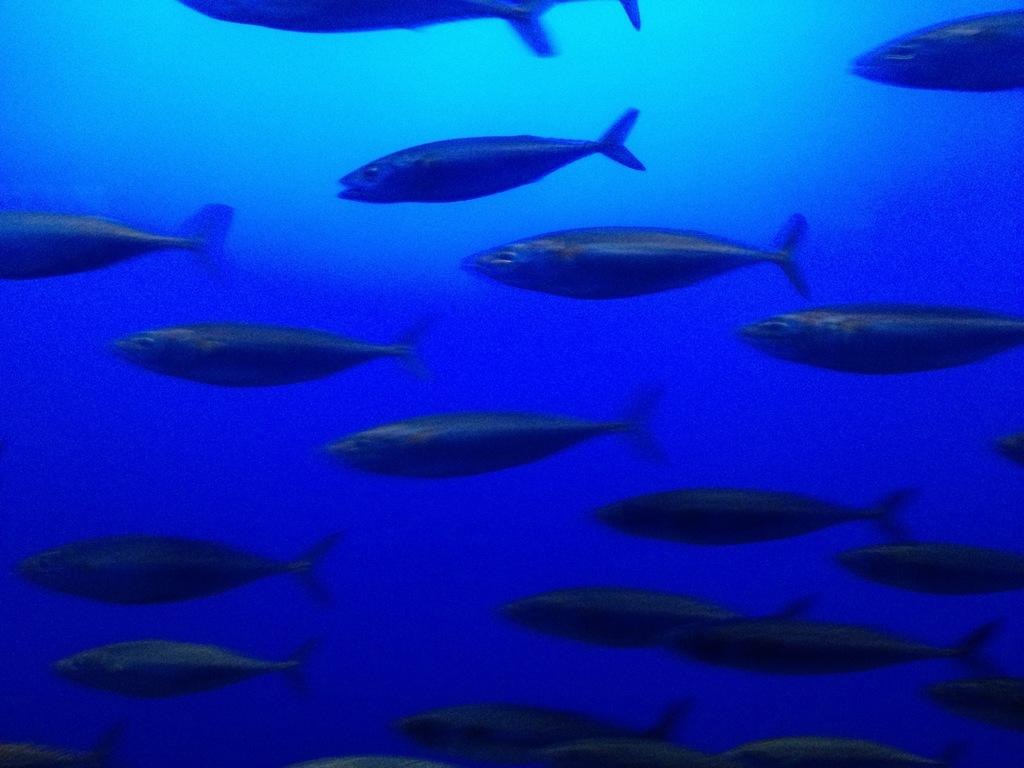What type of animals can be seen in the image? There is a group of fishes in the image. Where are the fishes located? The fishes are in the water. What suggestion do the fishes make to the viewer in the image? There is no suggestion made by the fishes in the image, as they are simply swimming in the water. 